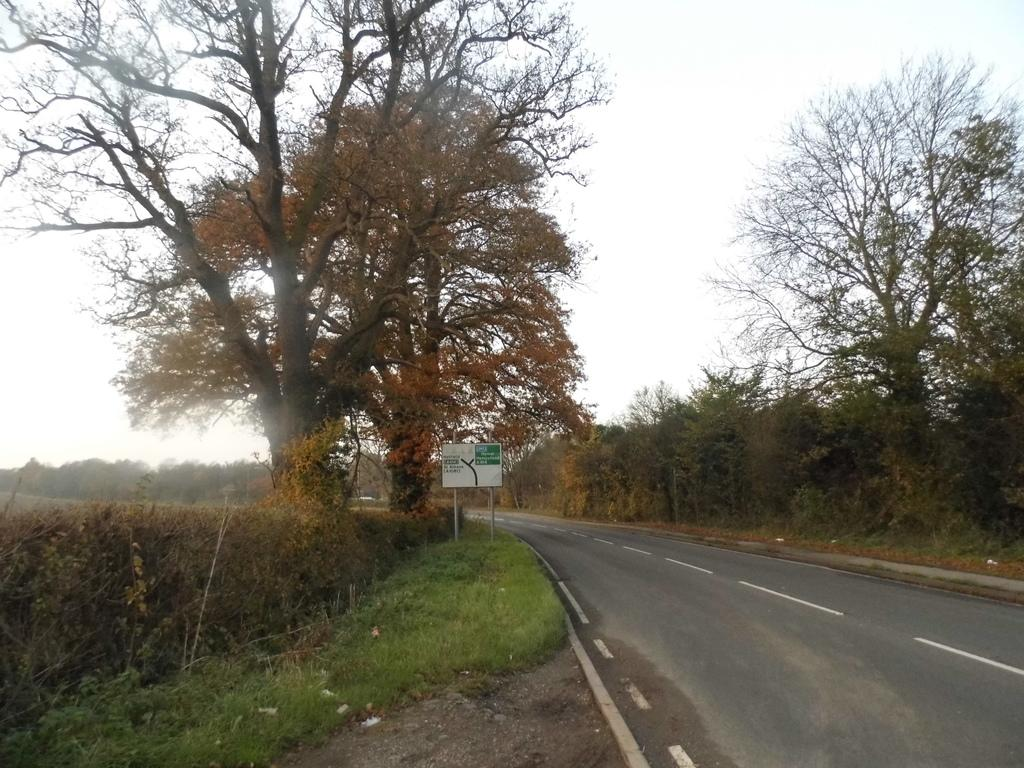What type of vegetation is present in the area? There are many trees in the area. What can be found on the ground beside the road? There is a hoarding on the ground beside the road. What covers the ground in the area? The ground is covered with grass. What type of trains can be seen passing by in the area? There are no trains visible in the image; it only shows trees, a hoarding, and grass-covered ground. What impulse might someone have while looking at the hoarding in the image? It is impossible to determine someone's impulse from the image, as it only shows the physical objects and not any people or their reactions. 